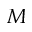<formula> <loc_0><loc_0><loc_500><loc_500>M</formula> 